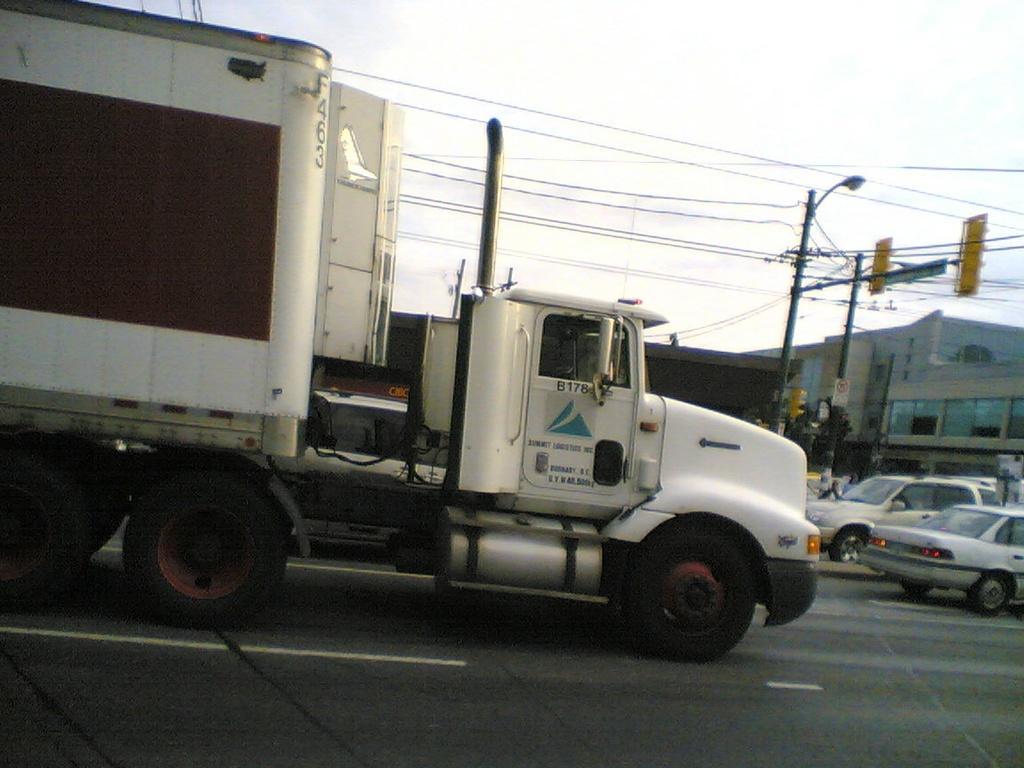How would you summarize this image in a sentence or two? In the picture we can see a truck on the road and near it, we can see some vehicles on the road and near it, we can see a pole with light and wires to it and in the background we can see some buildings and the sky. 